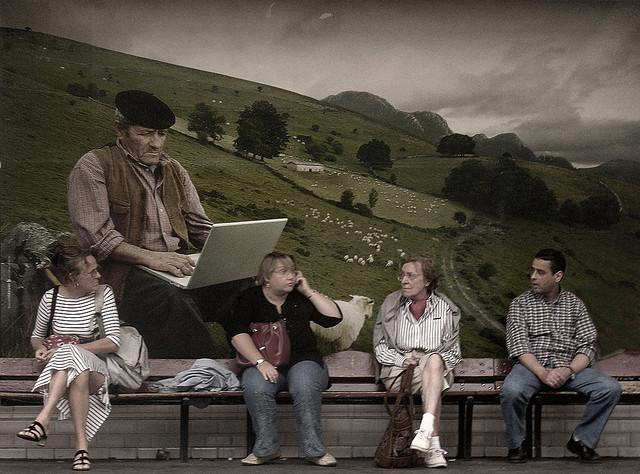What is the man in the mural using? laptop 